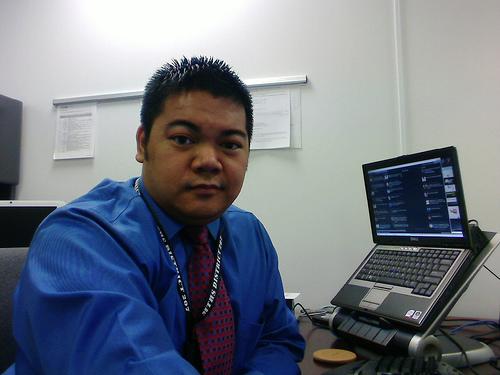What kind of garment is he wearing?
Short answer required. Shirt. What is the man talking on?
Concise answer only. Laptop. Does the laptop have a large screen?
Short answer required. No. Is the surfing on the net?
Quick response, please. Yes. Is the man wearing glasses?
Short answer required. No. Is there a dimmer switch in the background?
Keep it brief. No. What is on the man in blue's shirt?
Quick response, please. Tie. Is the man working on the laptop?
Short answer required. Yes. Where is the laptop?
Give a very brief answer. On stand. How many females in the photo?
Keep it brief. 0. Why is the other man mad?
Short answer required. He's not. What is the wall on the right made out of?
Write a very short answer. Drywall. Are they in a bar?
Give a very brief answer. No. Is he clean shaven?
Concise answer only. Yes. Did the guy in the picture shave this morning?
Keep it brief. Yes. What colors are the lanyard?
Keep it brief. Black. What color is this guys shirt?
Answer briefly. Blue. What color is the man's shirt?
Answer briefly. Blue. What type of electronic device is the man in the photo featured with?
Keep it brief. Laptop. What color is the man's tie?
Short answer required. Red and blue. 